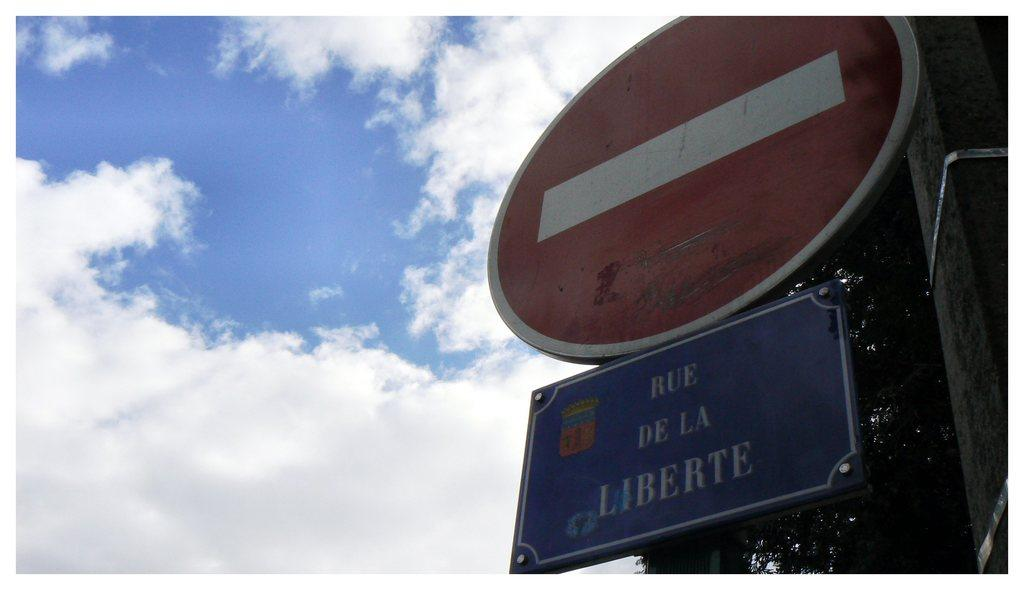Provide a one-sentence caption for the provided image. A sign reading Rue de la Liberte against a cloudy sky. 